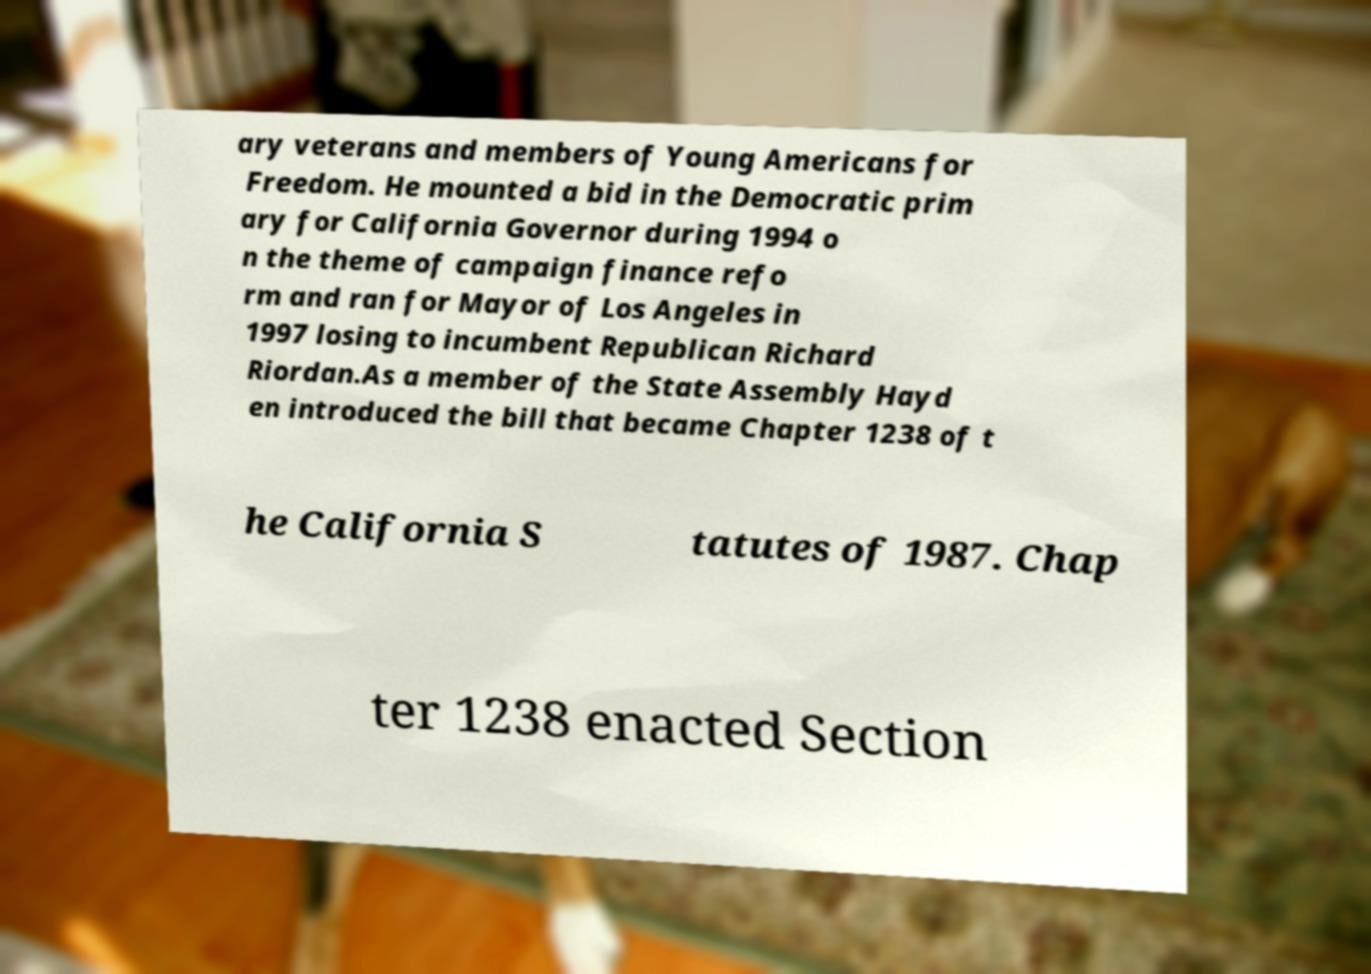Could you assist in decoding the text presented in this image and type it out clearly? ary veterans and members of Young Americans for Freedom. He mounted a bid in the Democratic prim ary for California Governor during 1994 o n the theme of campaign finance refo rm and ran for Mayor of Los Angeles in 1997 losing to incumbent Republican Richard Riordan.As a member of the State Assembly Hayd en introduced the bill that became Chapter 1238 of t he California S tatutes of 1987. Chap ter 1238 enacted Section 